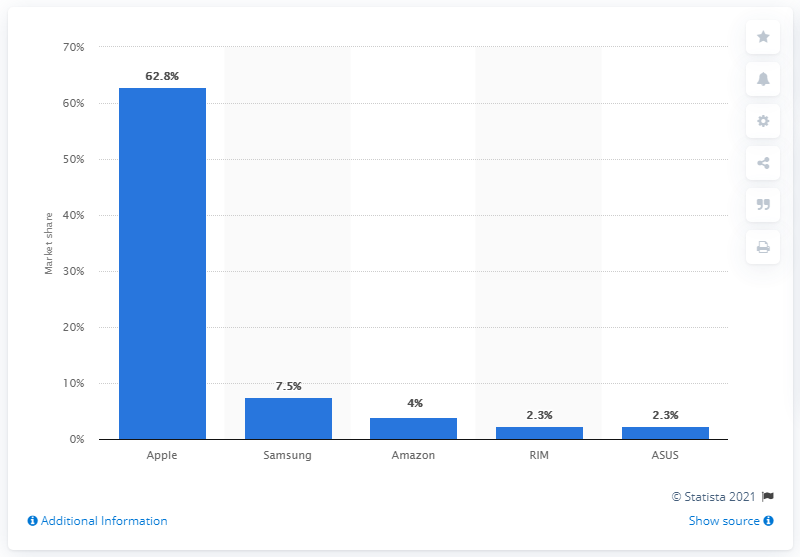Mention a couple of crucial points in this snapshot. In the first quarter of 2012, Apple accounted for 62.8% of the global tablet PC shipments. 